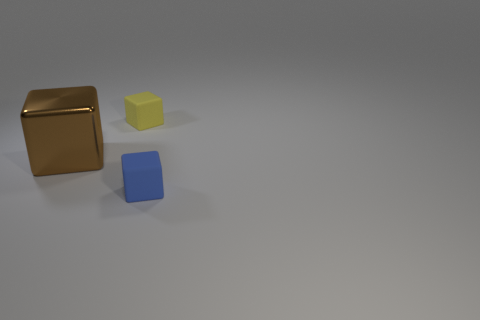There is a blue rubber thing; is its size the same as the matte cube that is behind the tiny blue rubber cube?
Make the answer very short. Yes. How many objects are big cyan matte blocks or blocks?
Provide a succinct answer. 3. Is there another yellow object made of the same material as the tiny yellow object?
Your answer should be very brief. No. What color is the tiny cube that is on the left side of the matte cube that is in front of the brown thing?
Provide a succinct answer. Yellow. Does the metallic cube have the same size as the yellow matte cube?
Give a very brief answer. No. What number of cylinders are tiny matte objects or small purple metal objects?
Provide a short and direct response. 0. There is a matte cube behind the big brown thing; what number of rubber blocks are to the right of it?
Provide a short and direct response. 1. Do the yellow object and the big brown shiny thing have the same shape?
Keep it short and to the point. Yes. What is the size of the blue rubber object that is the same shape as the yellow thing?
Provide a succinct answer. Small. What is the shape of the shiny thing that is behind the matte cube in front of the brown cube?
Make the answer very short. Cube. 